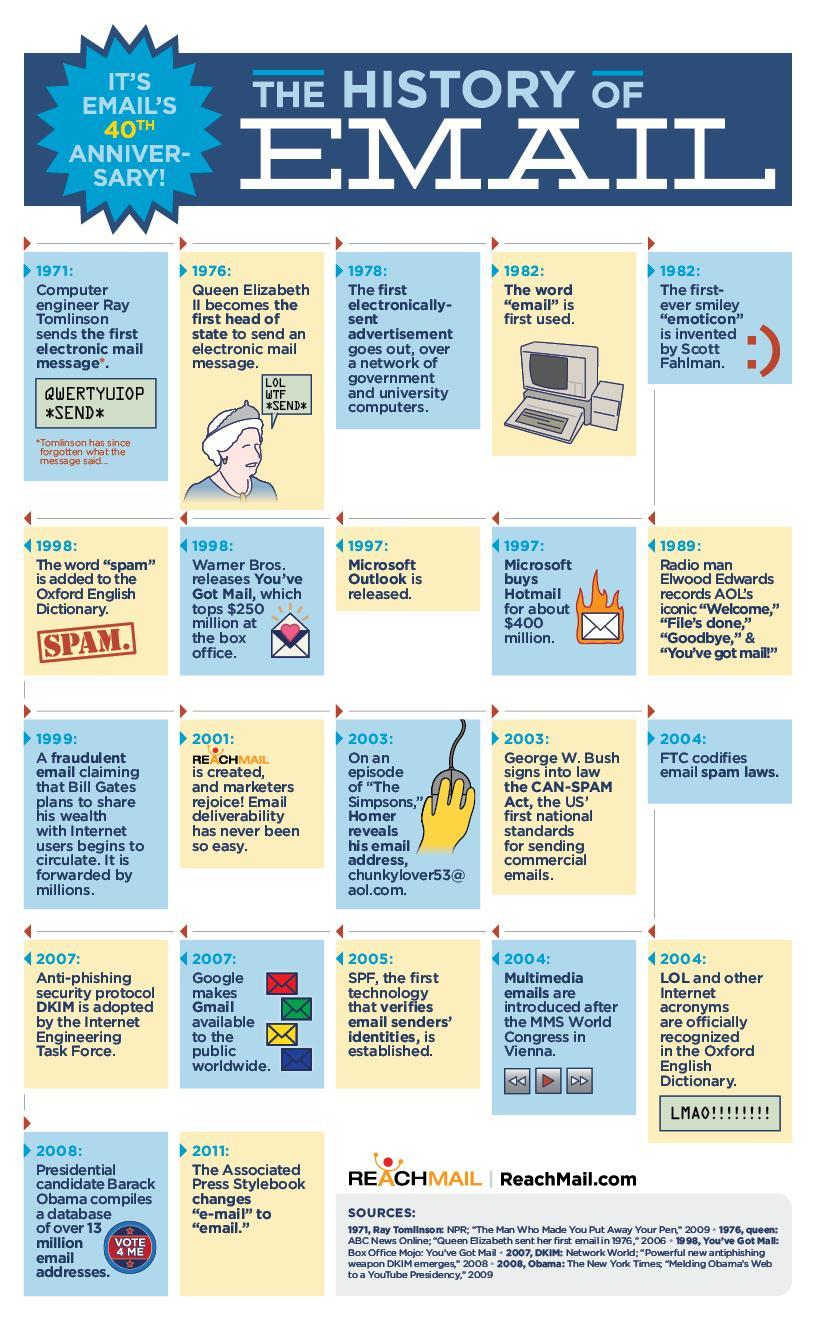Which year saw a political head send the first email?
Answer the question with a short phrase. 1976 Who was the first person to send an email, Queen Elizabeth, Scott, Fahlman, or Ray Tomlinson ? Ray Tomlinson Who introduced Got mail, Google, Microsoft, or Warner Bros? Warner Bros Who was first political leader to send an email, George W. Bush, Queen Elizabeth, or Elwood Edwards ? Queen Elizabeth Which year saw DKIM being adopted and the GMail being introduced? 2007 When did Microsoft introduce Outlook and also buy Hotmail? 1997 Which year saw three milestones achievements in the email history? 2004 When did the ratification for the laws to send spam mails take place, 2003, 2004, or 2007? 2003 